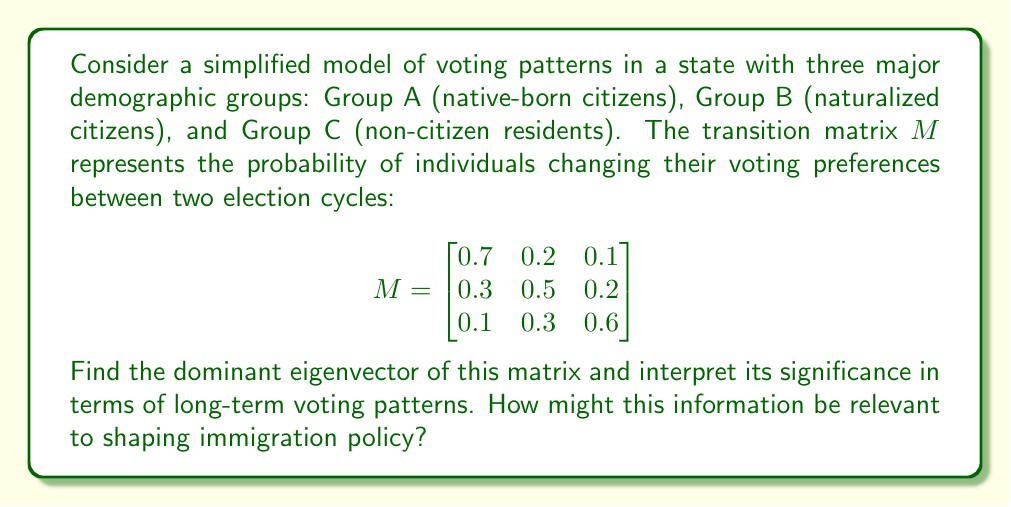Give your solution to this math problem. To find the dominant eigenvector, we need to:

1. Calculate the eigenvalues of matrix $M$
2. Identify the largest eigenvalue (in absolute value)
3. Find the corresponding eigenvector

Step 1: Calculate the eigenvalues
The characteristic equation is:
$$\det(M - \lambda I) = 0$$

$$\begin{vmatrix}
0.7 - \lambda & 0.2 & 0.1 \\
0.3 & 0.5 - \lambda & 0.2 \\
0.1 & 0.3 & 0.6 - \lambda
\end{vmatrix} = 0$$

Solving this equation gives us:
$$\lambda_1 \approx 1, \lambda_2 \approx 0.4, \lambda_3 \approx 0.4$$

Step 2: The dominant eigenvalue is $\lambda_1 = 1$

Step 3: Find the eigenvector $v$ corresponding to $\lambda_1 = 1$
Solve $(M - I)v = 0$:

$$\begin{bmatrix}
-0.3 & 0.2 & 0.1 \\
0.3 & -0.5 & 0.2 \\
0.1 & 0.3 & -0.4
\end{bmatrix} \begin{bmatrix} v_1 \\ v_2 \\ v_3 \end{bmatrix} = \begin{bmatrix} 0 \\ 0 \\ 0 \end{bmatrix}$$

Solving this system gives us the eigenvector:
$$v \approx \begin{bmatrix} 0.5556 \\ 0.3333 \\ 0.1111 \end{bmatrix}$$

Interpretation:
The dominant eigenvector represents the long-term stable distribution of voting preferences among the three demographic groups. It suggests that in the long run, approximately 55.56% of voters will align with Group A's preferences, 33.33% with Group B's, and 11.11% with Group C's.

This information is relevant to shaping immigration policy because:
1. It shows the potential long-term impact of naturalization on voting patterns.
2. It highlights the relative influence of each demographic group on election outcomes.
3. It can inform decisions about immigration rates and naturalization processes to maintain or alter the projected voting distribution.
Answer: The dominant eigenvector is approximately $v \approx [0.5556, 0.3333, 0.1111]^T$, indicating that in the long-term, voting preferences will stabilize with 55.56% aligning with Group A, 33.33% with Group B, and 11.11% with Group C. 